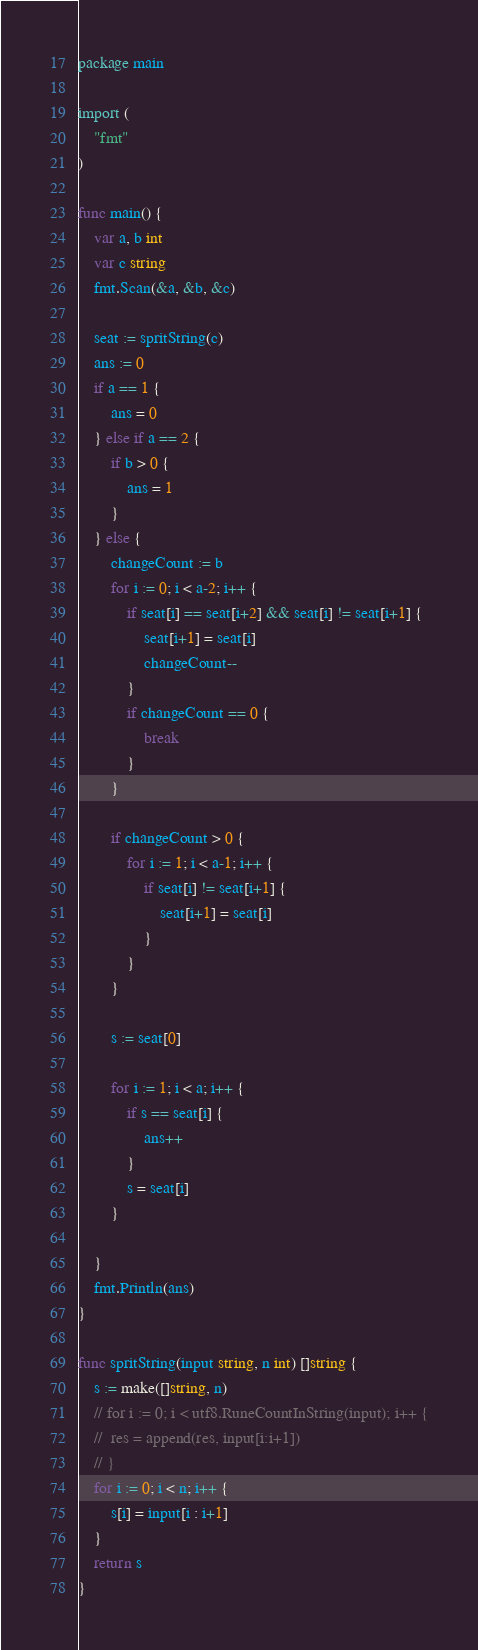<code> <loc_0><loc_0><loc_500><loc_500><_Go_>package main

import (
	"fmt"
)

func main() {
	var a, b int
	var c string
	fmt.Scan(&a, &b, &c)

	seat := spritString(c)
	ans := 0
	if a == 1 {
		ans = 0
	} else if a == 2 {
		if b > 0 {
			ans = 1
		}
	} else {
		changeCount := b
		for i := 0; i < a-2; i++ {
			if seat[i] == seat[i+2] && seat[i] != seat[i+1] {
				seat[i+1] = seat[i]
				changeCount--
			}
			if changeCount == 0 {
				break
			}
		}

		if changeCount > 0 {
			for i := 1; i < a-1; i++ {
				if seat[i] != seat[i+1] {
					seat[i+1] = seat[i]
				}
			}
		}

		s := seat[0]

		for i := 1; i < a; i++ {
			if s == seat[i] {
				ans++
			}
			s = seat[i]
		}

	}
	fmt.Println(ans)
}

func spritString(input string, n int) []string {
	s := make([]string, n)
	// for i := 0; i < utf8.RuneCountInString(input); i++ {
	// 	res = append(res, input[i:i+1])
	// }
	for i := 0; i < n; i++ {
		s[i] = input[i : i+1]
	}
	return s
}
</code> 